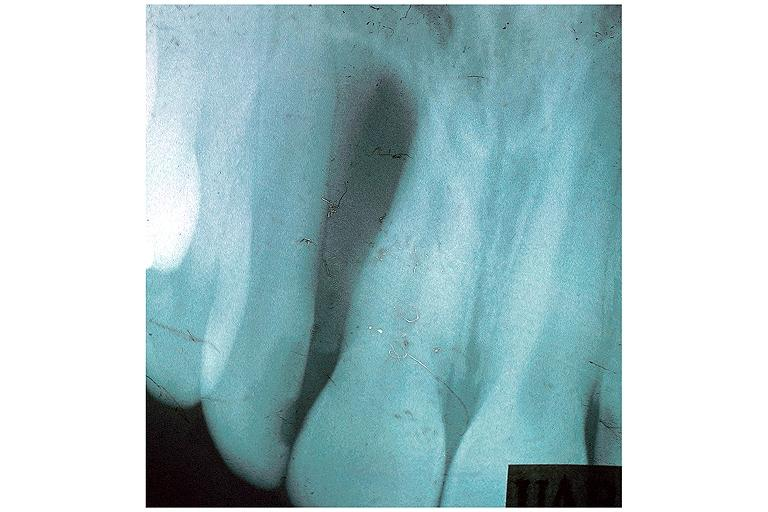what is present?
Answer the question using a single word or phrase. Oral 